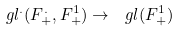<formula> <loc_0><loc_0><loc_500><loc_500>\ g l ^ { . } ( F ^ { . } _ { + } , F ^ { 1 } _ { + } ) \to \ g l ( F ^ { 1 } _ { + } )</formula> 